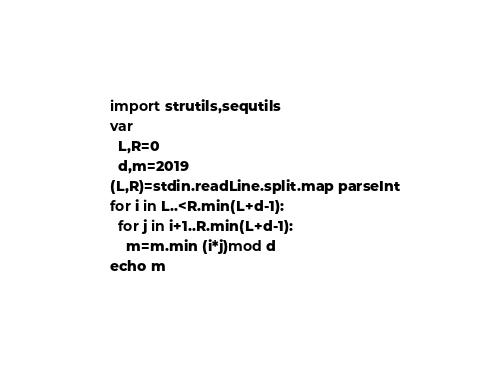Convert code to text. <code><loc_0><loc_0><loc_500><loc_500><_Nim_>import strutils,sequtils
var
  L,R=0
  d,m=2019
(L,R)=stdin.readLine.split.map parseInt
for i in L..<R.min(L+d-1):
  for j in i+1..R.min(L+d-1):
    m=m.min (i*j)mod d
echo m</code> 